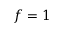<formula> <loc_0><loc_0><loc_500><loc_500>f = 1</formula> 